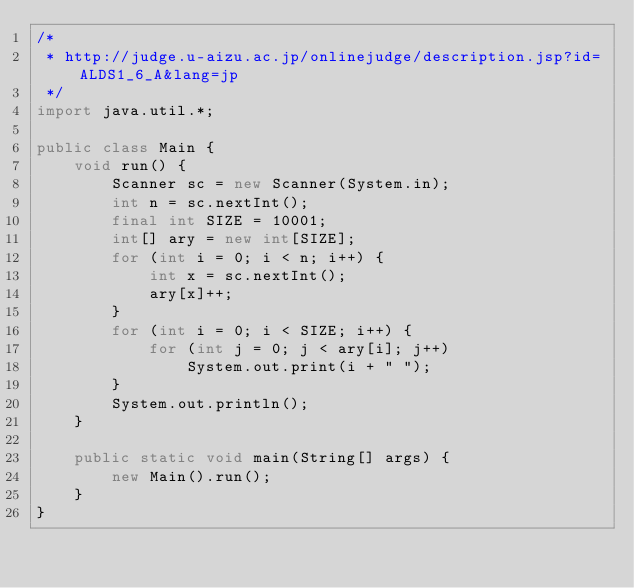<code> <loc_0><loc_0><loc_500><loc_500><_Java_>/*
 * http://judge.u-aizu.ac.jp/onlinejudge/description.jsp?id=ALDS1_6_A&lang=jp
 */
import java.util.*;

public class Main {
    void run() {
        Scanner sc = new Scanner(System.in);
        int n = sc.nextInt();
        final int SIZE = 10001;
        int[] ary = new int[SIZE];
        for (int i = 0; i < n; i++) {
            int x = sc.nextInt();
            ary[x]++;
        }
        for (int i = 0; i < SIZE; i++) {
            for (int j = 0; j < ary[i]; j++)
                System.out.print(i + " ");
        }
        System.out.println();
    }

    public static void main(String[] args) {
        new Main().run();
    }
}
</code> 